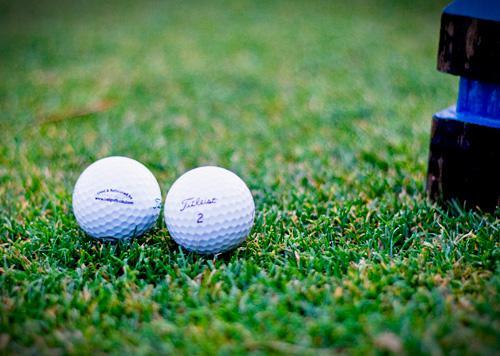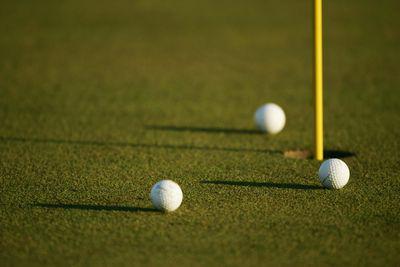The first image is the image on the left, the second image is the image on the right. Analyze the images presented: Is the assertion "In one of the images there are at least two golf balls positioned near a hole with a golf flagpole inserted in it." valid? Answer yes or no. Yes. The first image is the image on the left, the second image is the image on the right. Assess this claim about the two images: "An image shows multiple golf balls near a hole with a pole in it.". Correct or not? Answer yes or no. Yes. 